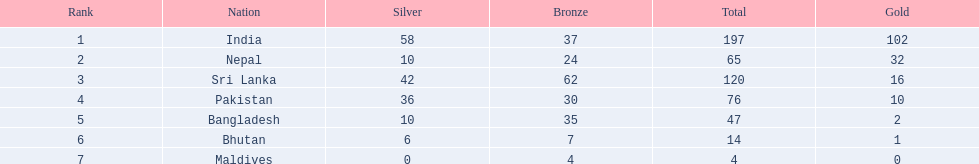Could you parse the entire table as a dict? {'header': ['Rank', 'Nation', 'Silver', 'Bronze', 'Total', 'Gold'], 'rows': [['1', 'India', '58', '37', '197', '102'], ['2', 'Nepal', '10', '24', '65', '32'], ['3', 'Sri Lanka', '42', '62', '120', '16'], ['4', 'Pakistan', '36', '30', '76', '10'], ['5', 'Bangladesh', '10', '35', '47', '2'], ['6', 'Bhutan', '6', '7', '14', '1'], ['7', 'Maldives', '0', '4', '4', '0']]} Which nations played at the 1999 south asian games? India, Nepal, Sri Lanka, Pakistan, Bangladesh, Bhutan, Maldives. Which country is listed second in the table? Nepal. 